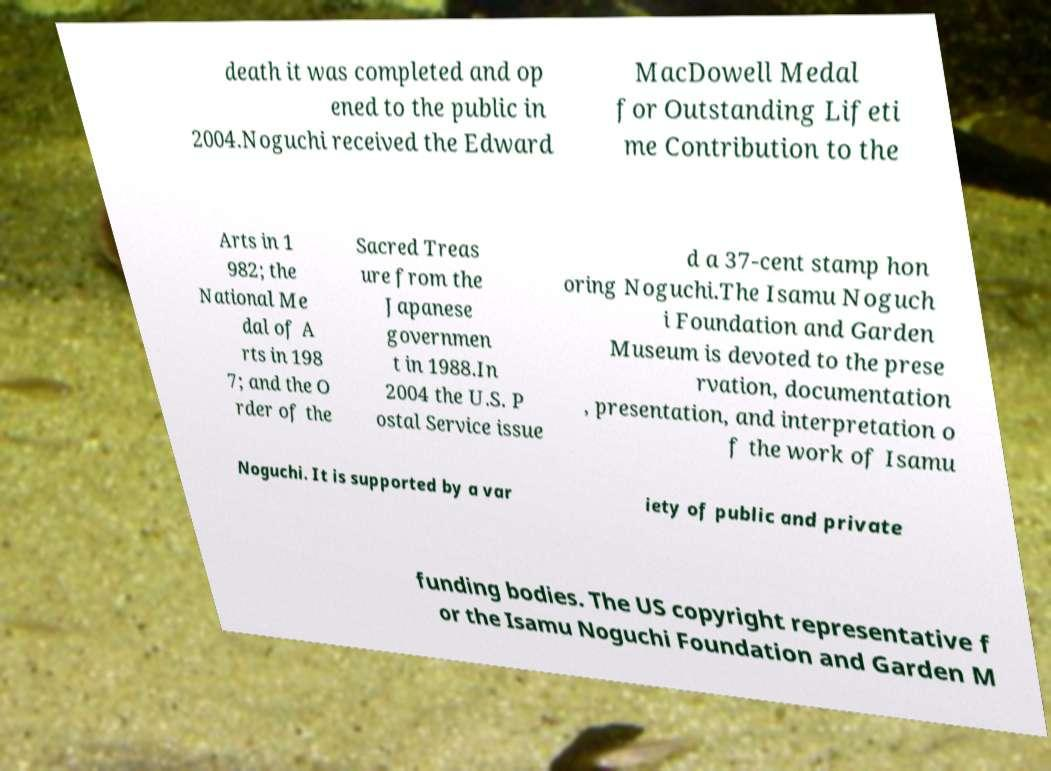What messages or text are displayed in this image? I need them in a readable, typed format. death it was completed and op ened to the public in 2004.Noguchi received the Edward MacDowell Medal for Outstanding Lifeti me Contribution to the Arts in 1 982; the National Me dal of A rts in 198 7; and the O rder of the Sacred Treas ure from the Japanese governmen t in 1988.In 2004 the U.S. P ostal Service issue d a 37-cent stamp hon oring Noguchi.The Isamu Noguch i Foundation and Garden Museum is devoted to the prese rvation, documentation , presentation, and interpretation o f the work of Isamu Noguchi. It is supported by a var iety of public and private funding bodies. The US copyright representative f or the Isamu Noguchi Foundation and Garden M 